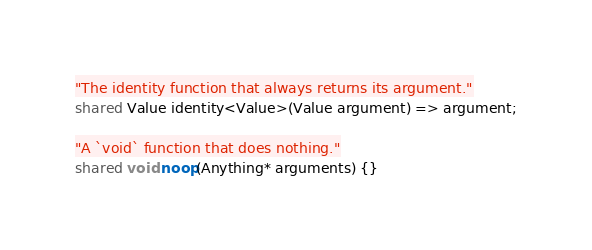Convert code to text. <code><loc_0><loc_0><loc_500><loc_500><_Ceylon_>"The identity function that always returns its argument."
shared Value identity<Value>(Value argument) => argument;

"A `void` function that does nothing."
shared void noop(Anything* arguments) {}
</code> 